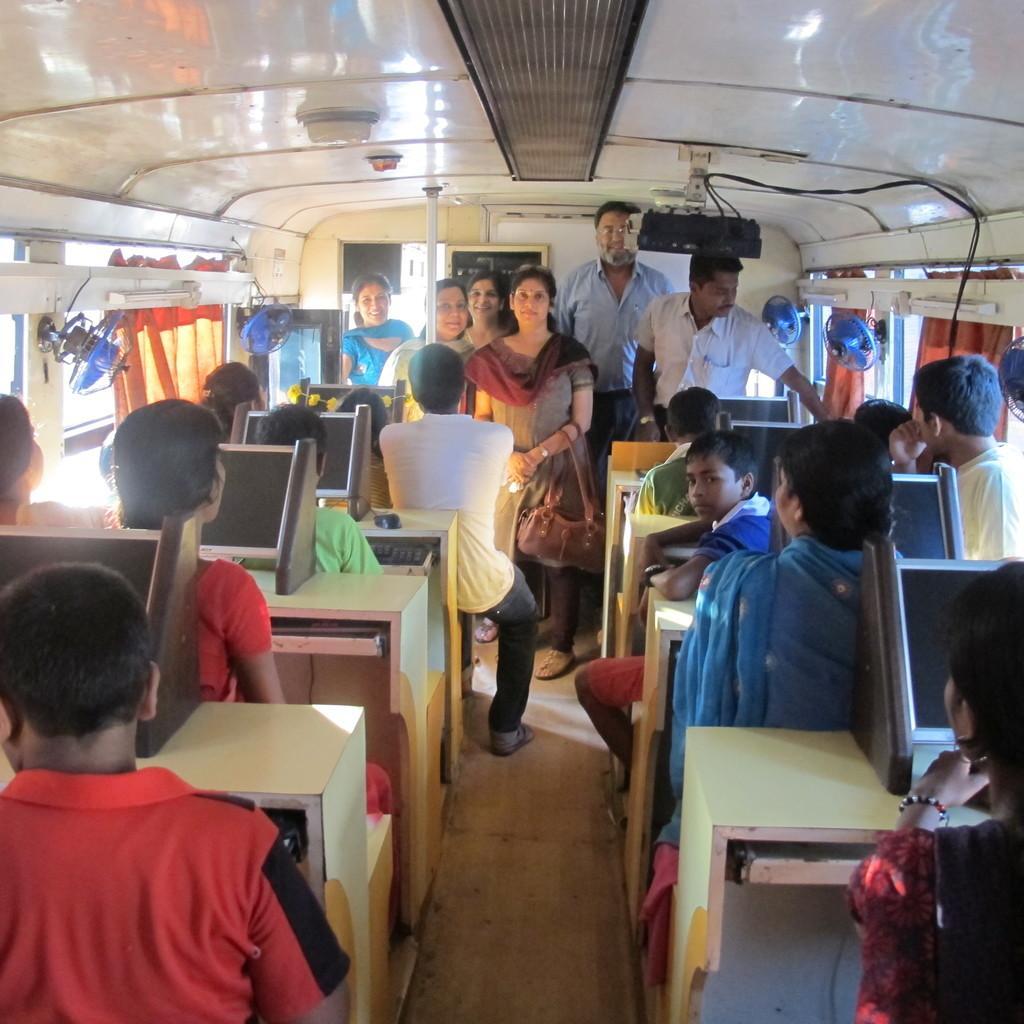Please provide a concise description of this image. This image is clicked in a vehicle. There are many persons in this image. And there are also many tables on which monitors are fixed. In the front, there are some people standing. To the left, there are fans. At the top, there are lights. 